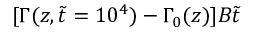Convert formula to latex. <formula><loc_0><loc_0><loc_500><loc_500>[ \Gamma ( z , \tilde { t } = 1 0 ^ { 4 } ) - \Gamma _ { 0 } ( z ) ] B \tilde { t }</formula> 